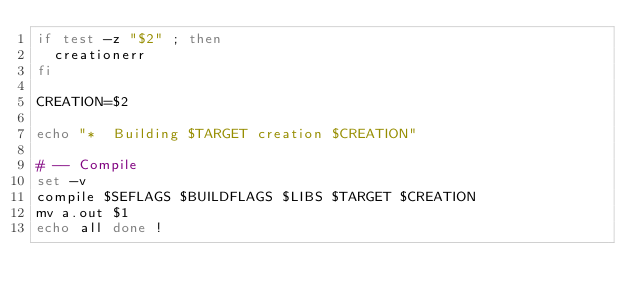Convert code to text. <code><loc_0><loc_0><loc_500><loc_500><_Bash_>if test -z "$2" ; then
	creationerr 
fi

CREATION=$2

echo "*  Building $TARGET creation $CREATION"

# -- Compile
set -v 
compile $SEFLAGS $BUILDFLAGS $LIBS $TARGET $CREATION
mv a.out $1
echo all done !

 
</code> 